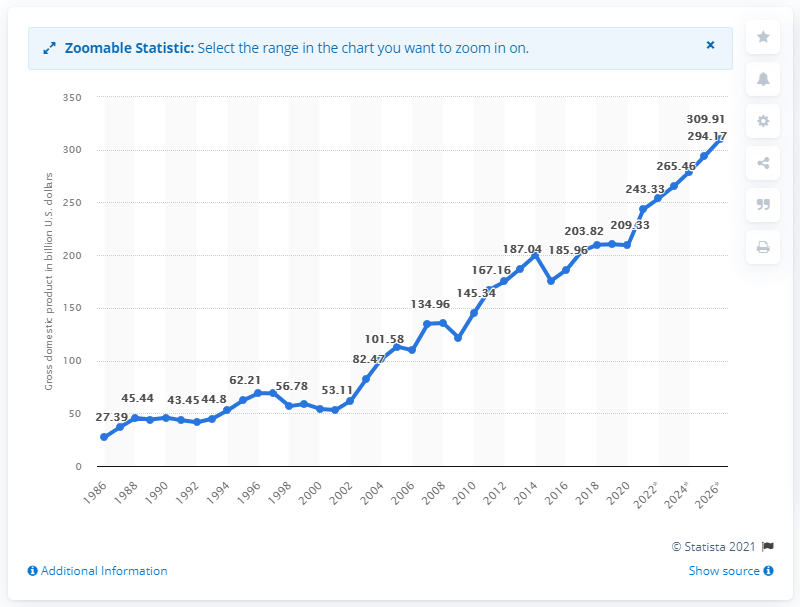Point out several critical features in this image. In 2020, New Zealand's gross domestic product (GDP) in dollars was 209.33. 